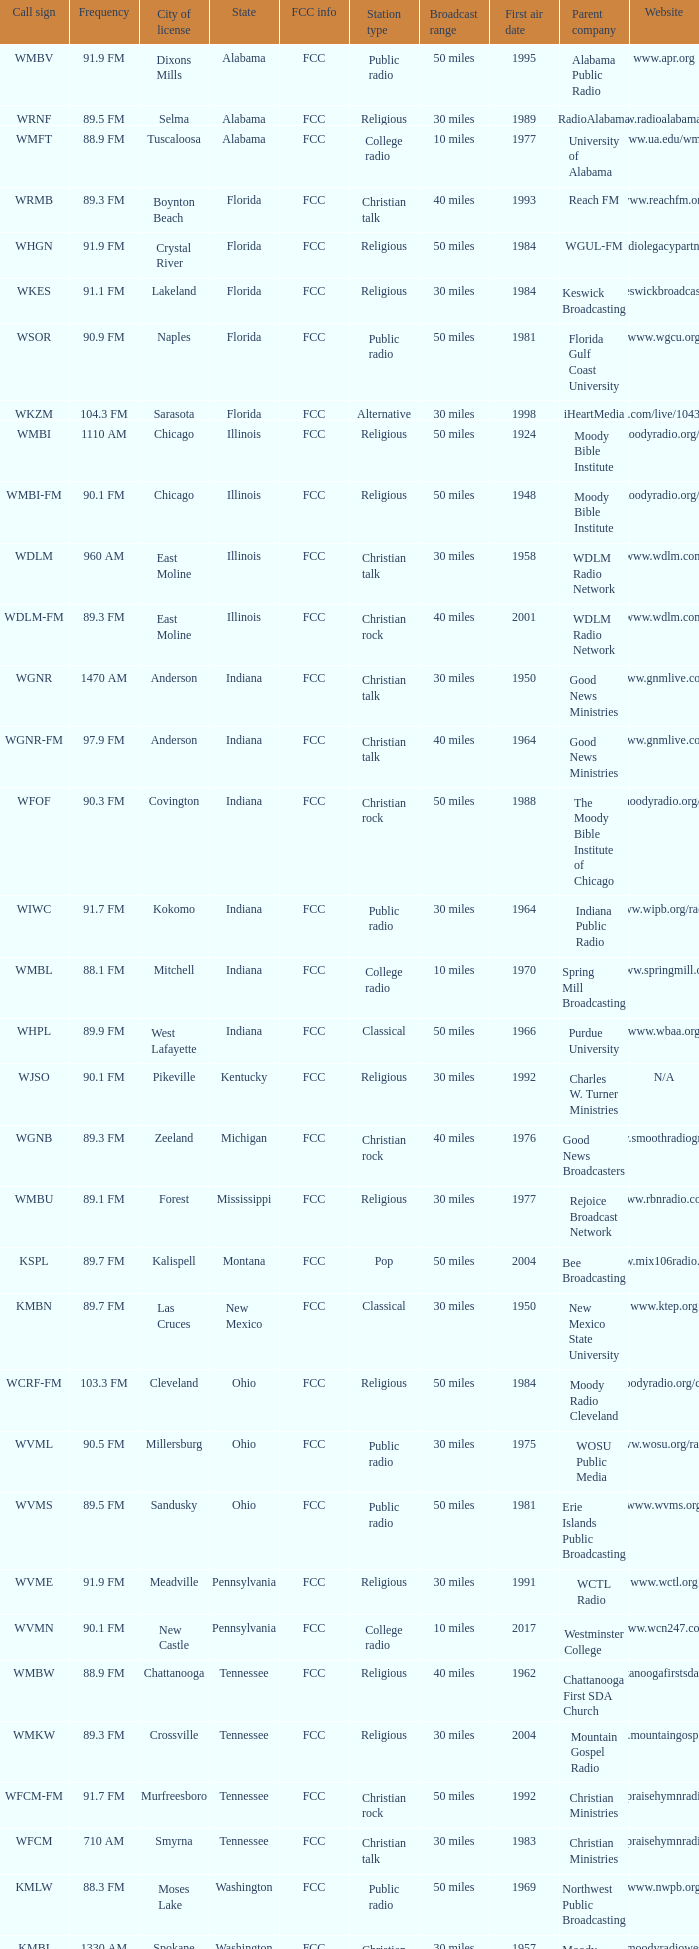With a frequency of 90.1 fm and a new castle city license, what state is the radio station based in? Pennsylvania. 